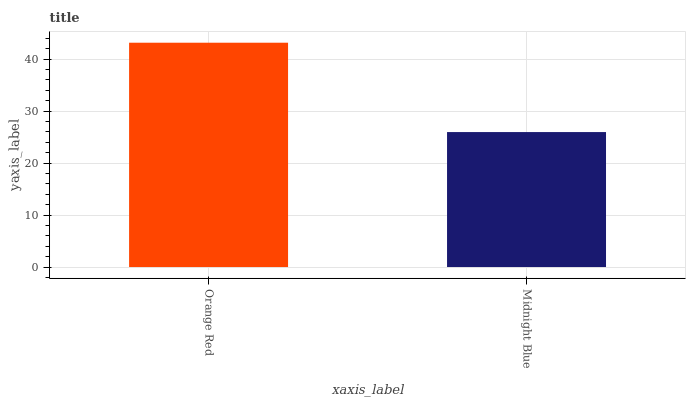Is Midnight Blue the minimum?
Answer yes or no. Yes. Is Orange Red the maximum?
Answer yes or no. Yes. Is Midnight Blue the maximum?
Answer yes or no. No. Is Orange Red greater than Midnight Blue?
Answer yes or no. Yes. Is Midnight Blue less than Orange Red?
Answer yes or no. Yes. Is Midnight Blue greater than Orange Red?
Answer yes or no. No. Is Orange Red less than Midnight Blue?
Answer yes or no. No. Is Orange Red the high median?
Answer yes or no. Yes. Is Midnight Blue the low median?
Answer yes or no. Yes. Is Midnight Blue the high median?
Answer yes or no. No. Is Orange Red the low median?
Answer yes or no. No. 